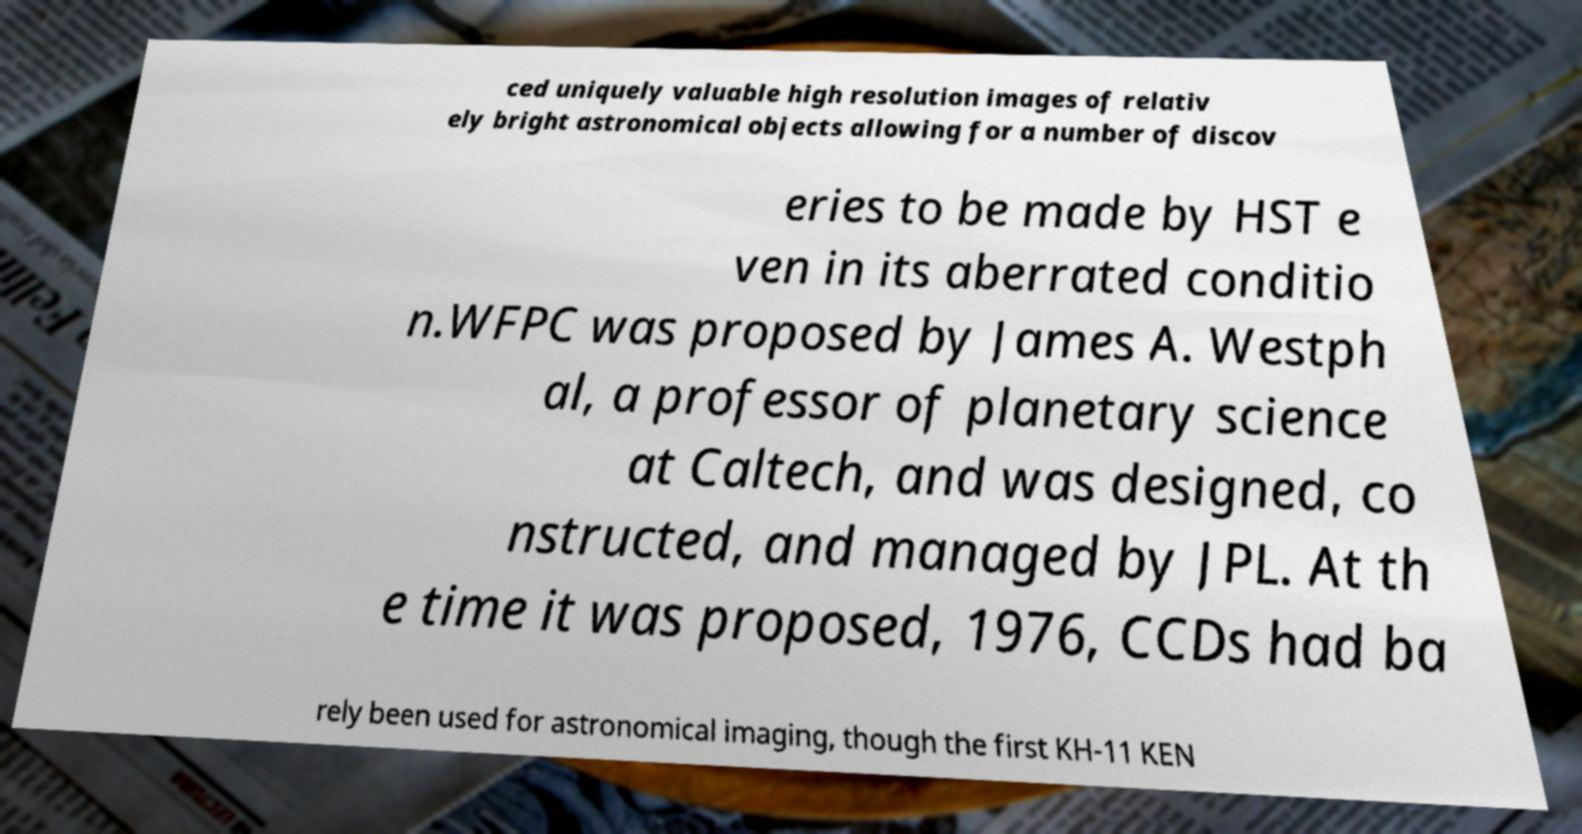Can you accurately transcribe the text from the provided image for me? ced uniquely valuable high resolution images of relativ ely bright astronomical objects allowing for a number of discov eries to be made by HST e ven in its aberrated conditio n.WFPC was proposed by James A. Westph al, a professor of planetary science at Caltech, and was designed, co nstructed, and managed by JPL. At th e time it was proposed, 1976, CCDs had ba rely been used for astronomical imaging, though the first KH-11 KEN 